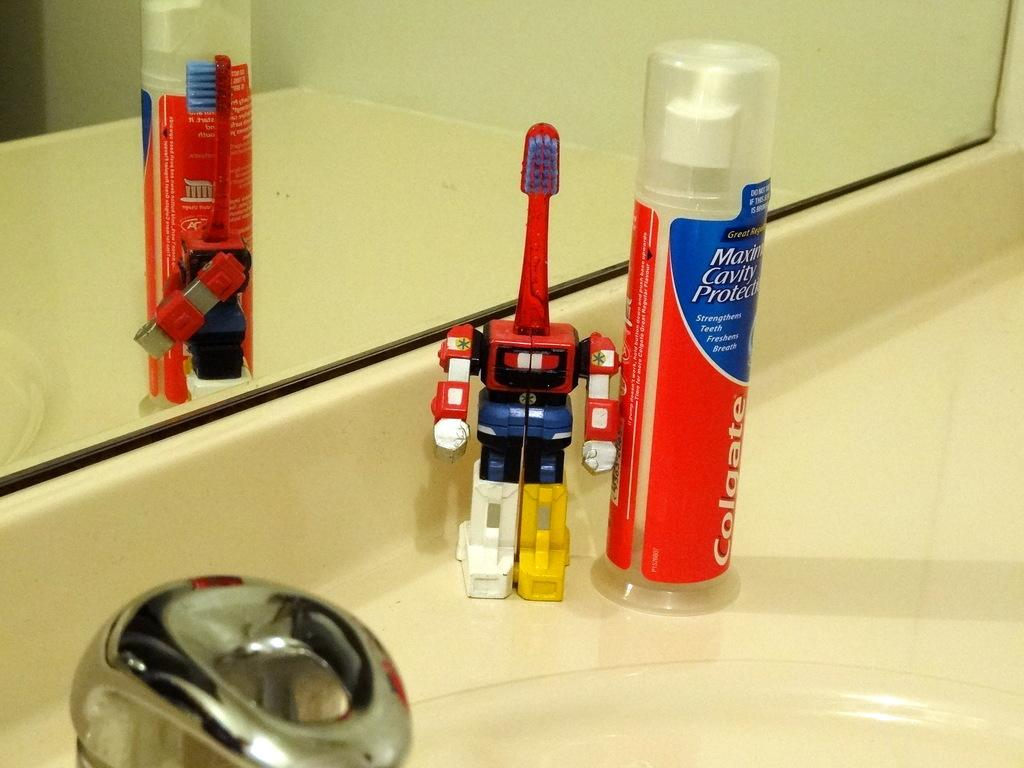<image>
Offer a succinct explanation of the picture presented. A robot toothbrush sits next to a container of Colgate toothpaste. 